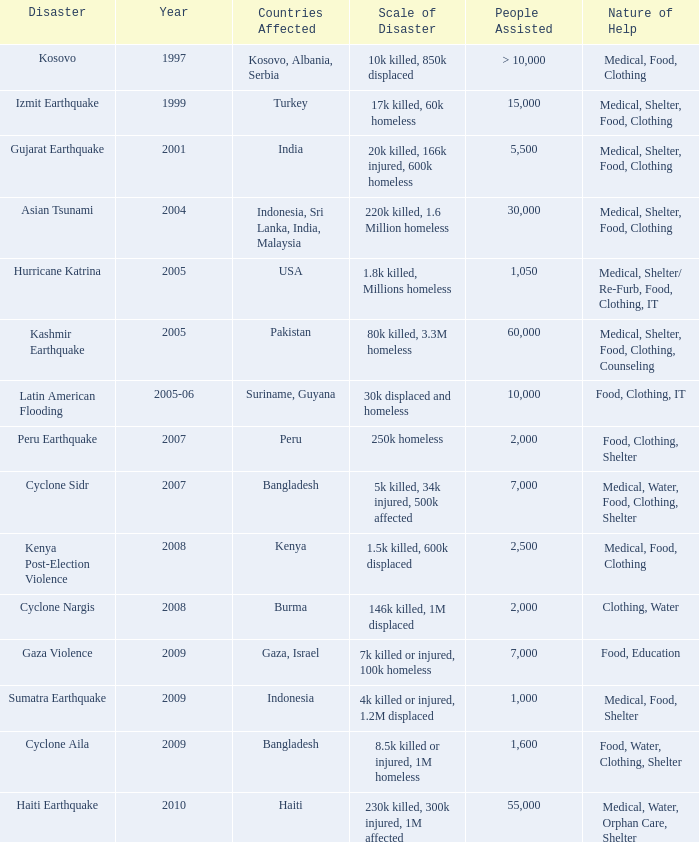How many people were assisted in 1997? > 10,000. 